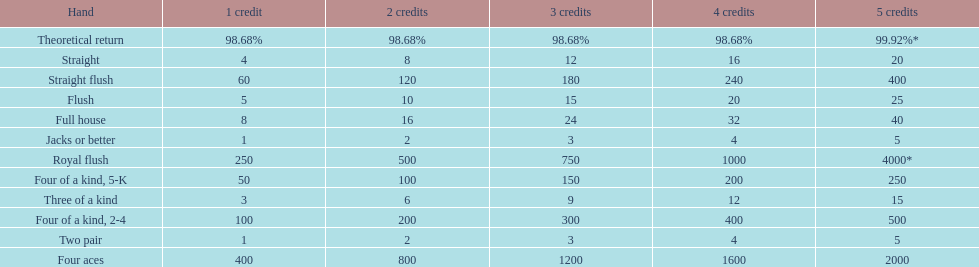What is the difference of payout on 3 credits, between a straight flush and royal flush? 570. 